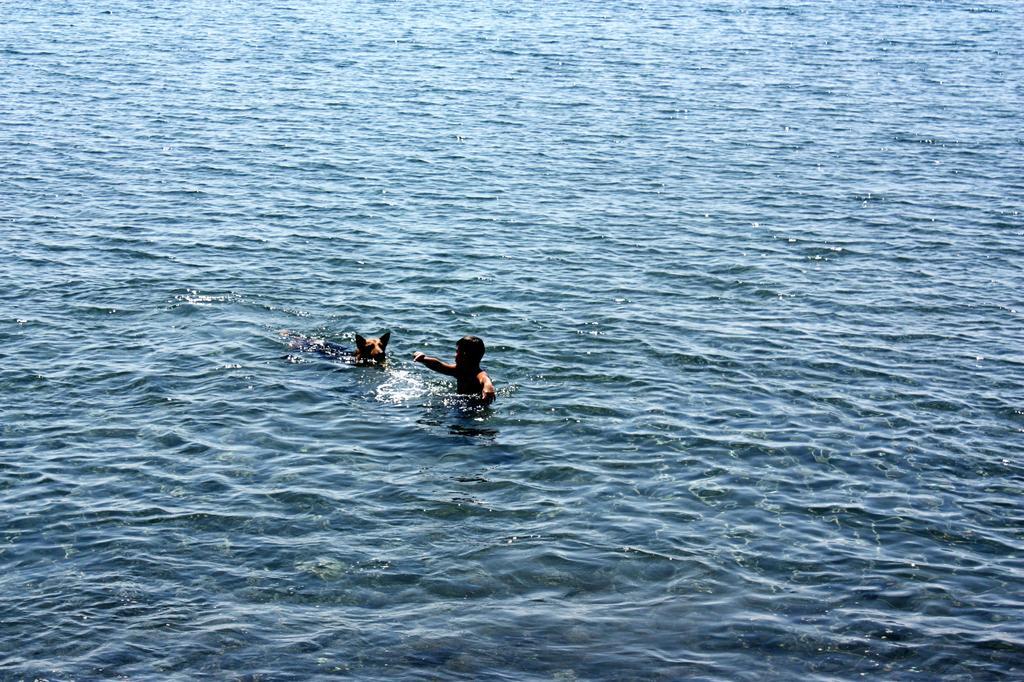Describe this image in one or two sentences. In this image there is water and we can see a man and a dog in the water. 